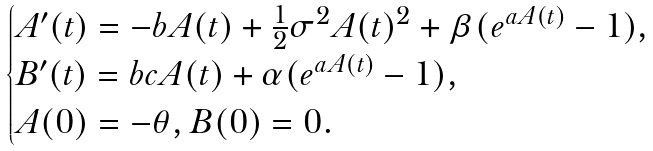Convert formula to latex. <formula><loc_0><loc_0><loc_500><loc_500>\begin{cases} A ^ { \prime } ( t ) = - b A ( t ) + \frac { 1 } { 2 } \sigma ^ { 2 } A ( t ) ^ { 2 } + \beta ( e ^ { a A ( t ) } - 1 ) , \\ B ^ { \prime } ( t ) = b c A ( t ) + \alpha ( e ^ { a A ( t ) } - 1 ) , \\ A ( 0 ) = - \theta , B ( 0 ) = 0 . \end{cases}</formula> 